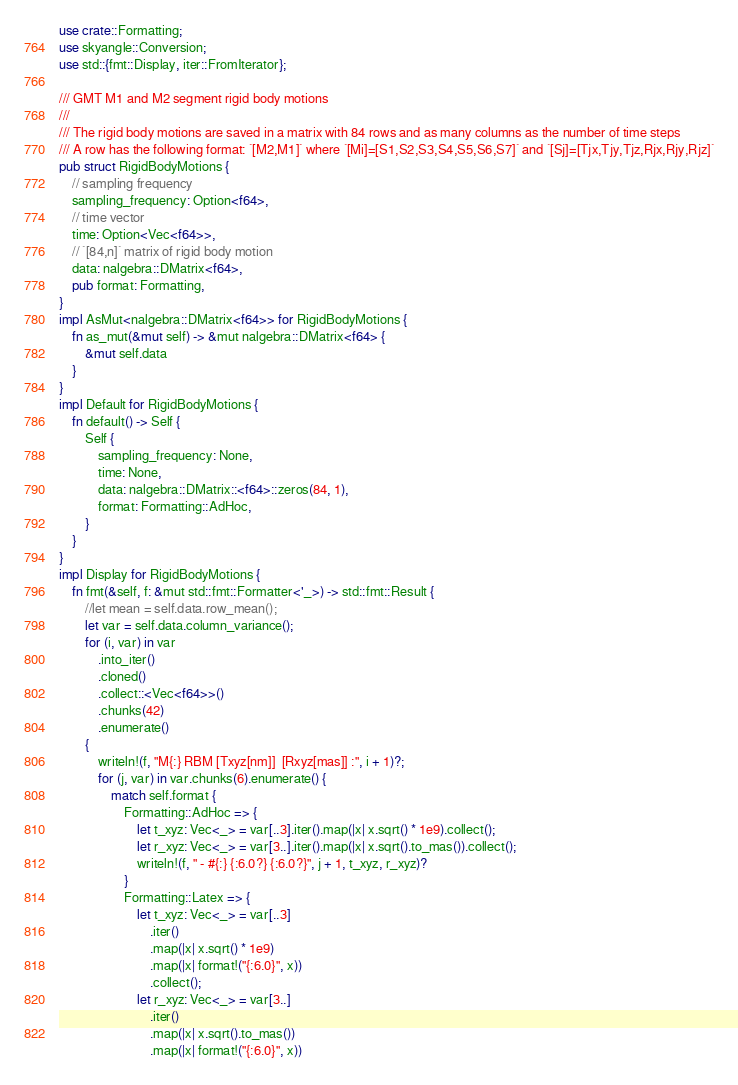<code> <loc_0><loc_0><loc_500><loc_500><_Rust_>use crate::Formatting;
use skyangle::Conversion;
use std::{fmt::Display, iter::FromIterator};

/// GMT M1 and M2 segment rigid body motions
///
/// The rigid body motions are saved in a matrix with 84 rows and as many columns as the number of time steps
/// A row has the following format: `[M2,M1]` where `[Mi]=[S1,S2,S3,S4,S5,S6,S7]` and `[Sj]=[Tjx,Tjy,Tjz,Rjx,Rjy,Rjz]`
pub struct RigidBodyMotions {
    // sampling frequency
    sampling_frequency: Option<f64>,
    // time vector
    time: Option<Vec<f64>>,
    // `[84,n]` matrix of rigid body motion
    data: nalgebra::DMatrix<f64>,
    pub format: Formatting,
}
impl AsMut<nalgebra::DMatrix<f64>> for RigidBodyMotions {
    fn as_mut(&mut self) -> &mut nalgebra::DMatrix<f64> {
        &mut self.data
    }
}
impl Default for RigidBodyMotions {
    fn default() -> Self {
        Self {
            sampling_frequency: None,
            time: None,
            data: nalgebra::DMatrix::<f64>::zeros(84, 1),
            format: Formatting::AdHoc,
        }
    }
}
impl Display for RigidBodyMotions {
    fn fmt(&self, f: &mut std::fmt::Formatter<'_>) -> std::fmt::Result {
        //let mean = self.data.row_mean();
        let var = self.data.column_variance();
        for (i, var) in var
            .into_iter()
            .cloned()
            .collect::<Vec<f64>>()
            .chunks(42)
            .enumerate()
        {
            writeln!(f, "M{:} RBM [Txyz[nm]]  [Rxyz[mas]] :", i + 1)?;
            for (j, var) in var.chunks(6).enumerate() {
                match self.format {
                    Formatting::AdHoc => {
                        let t_xyz: Vec<_> = var[..3].iter().map(|x| x.sqrt() * 1e9).collect();
                        let r_xyz: Vec<_> = var[3..].iter().map(|x| x.sqrt().to_mas()).collect();
                        writeln!(f, " - #{:} {:6.0?} {:6.0?}", j + 1, t_xyz, r_xyz)?
                    }
                    Formatting::Latex => {
                        let t_xyz: Vec<_> = var[..3]
                            .iter()
                            .map(|x| x.sqrt() * 1e9)
                            .map(|x| format!("{:6.0}", x))
                            .collect();
                        let r_xyz: Vec<_> = var[3..]
                            .iter()
                            .map(|x| x.sqrt().to_mas())
                            .map(|x| format!("{:6.0}", x))</code> 